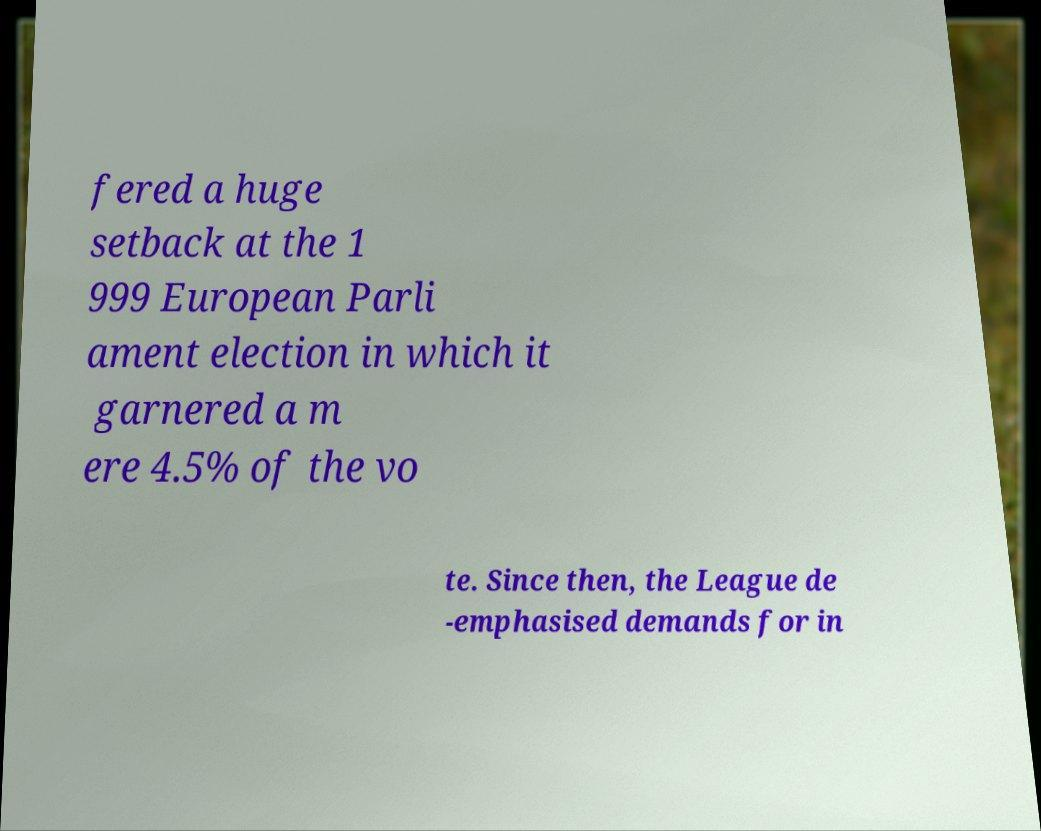Could you assist in decoding the text presented in this image and type it out clearly? fered a huge setback at the 1 999 European Parli ament election in which it garnered a m ere 4.5% of the vo te. Since then, the League de -emphasised demands for in 